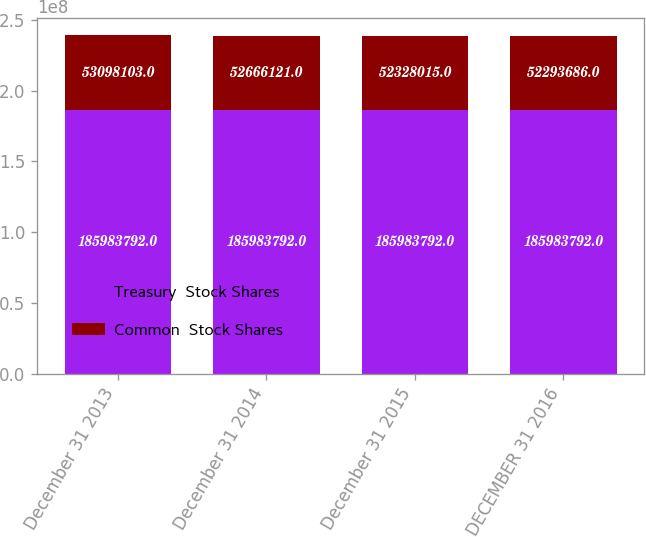Convert chart to OTSL. <chart><loc_0><loc_0><loc_500><loc_500><stacked_bar_chart><ecel><fcel>December 31 2013<fcel>December 31 2014<fcel>December 31 2015<fcel>DECEMBER 31 2016<nl><fcel>Treasury  Stock Shares<fcel>1.85984e+08<fcel>1.85984e+08<fcel>1.85984e+08<fcel>1.85984e+08<nl><fcel>Common  Stock Shares<fcel>5.30981e+07<fcel>5.26661e+07<fcel>5.2328e+07<fcel>5.22937e+07<nl></chart> 